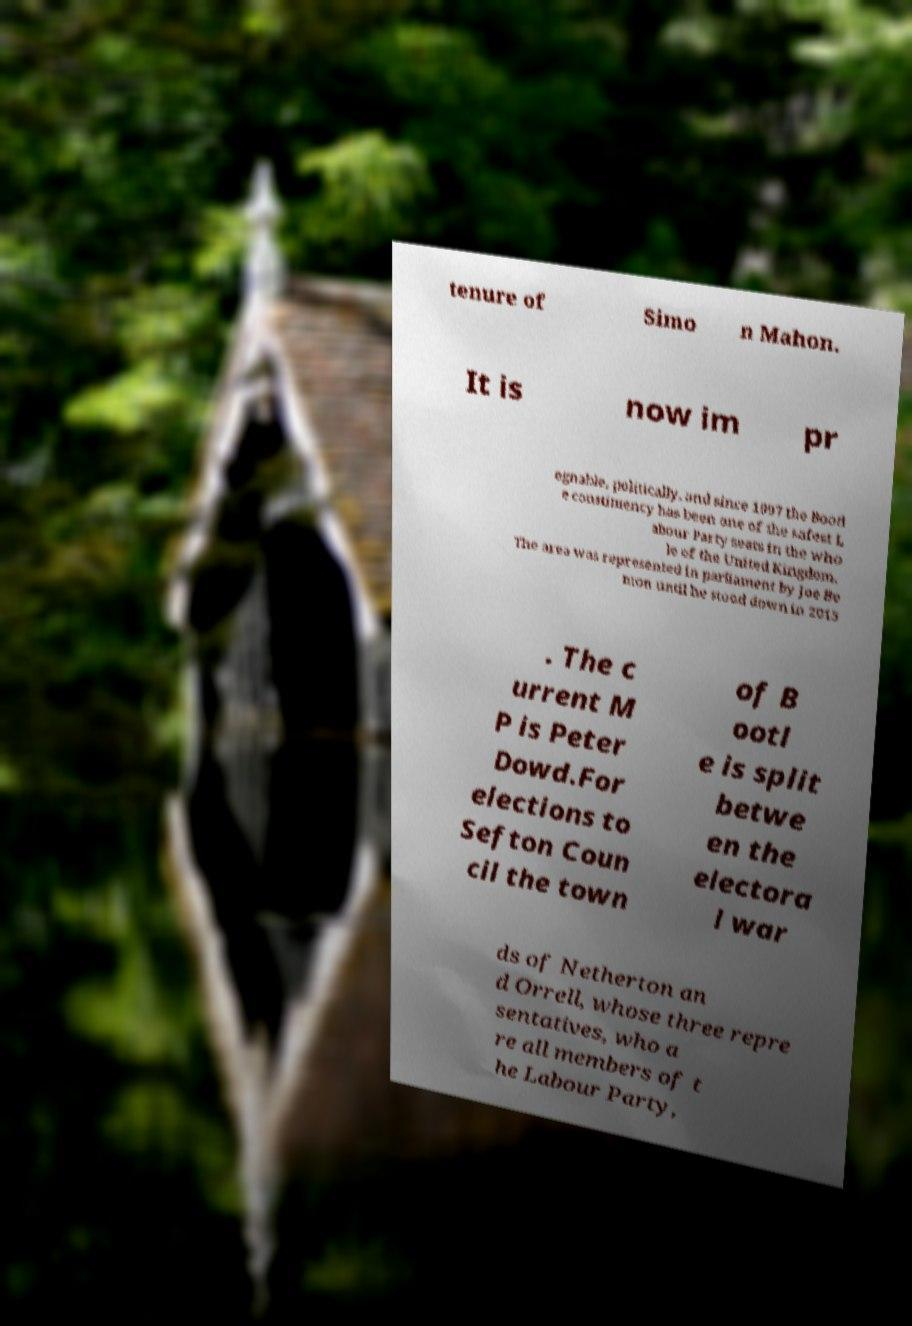Can you accurately transcribe the text from the provided image for me? tenure of Simo n Mahon. It is now im pr egnable, politically, and since 1997 the Bootl e constituency has been one of the safest L abour Party seats in the who le of the United Kingdom. The area was represented in parliament by Joe Be nton until he stood down in 2015 . The c urrent M P is Peter Dowd.For elections to Sefton Coun cil the town of B ootl e is split betwe en the electora l war ds of Netherton an d Orrell, whose three repre sentatives, who a re all members of t he Labour Party, 